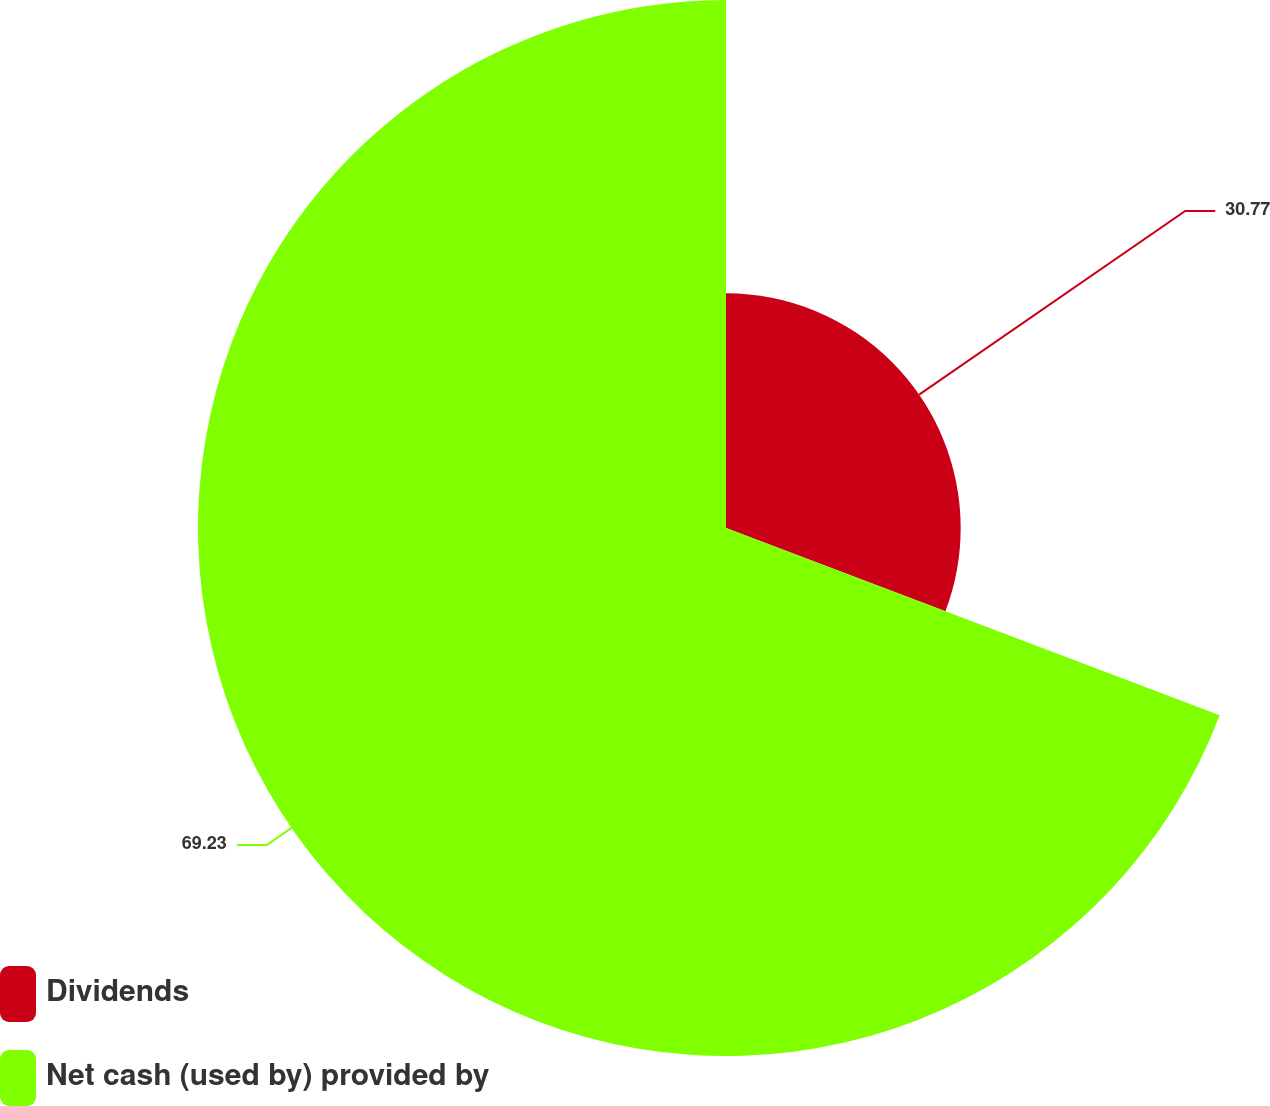Convert chart. <chart><loc_0><loc_0><loc_500><loc_500><pie_chart><fcel>Dividends<fcel>Net cash (used by) provided by<nl><fcel>30.77%<fcel>69.23%<nl></chart> 